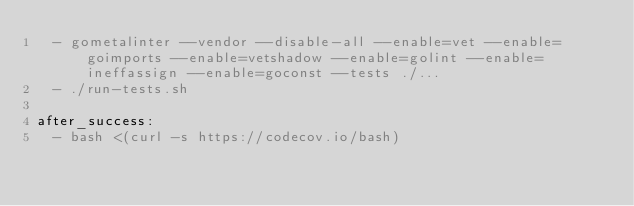<code> <loc_0><loc_0><loc_500><loc_500><_YAML_>  - gometalinter --vendor --disable-all --enable=vet --enable=goimports --enable=vetshadow --enable=golint --enable=ineffassign --enable=goconst --tests ./...
  - ./run-tests.sh

after_success:
  - bash <(curl -s https://codecov.io/bash)
</code> 